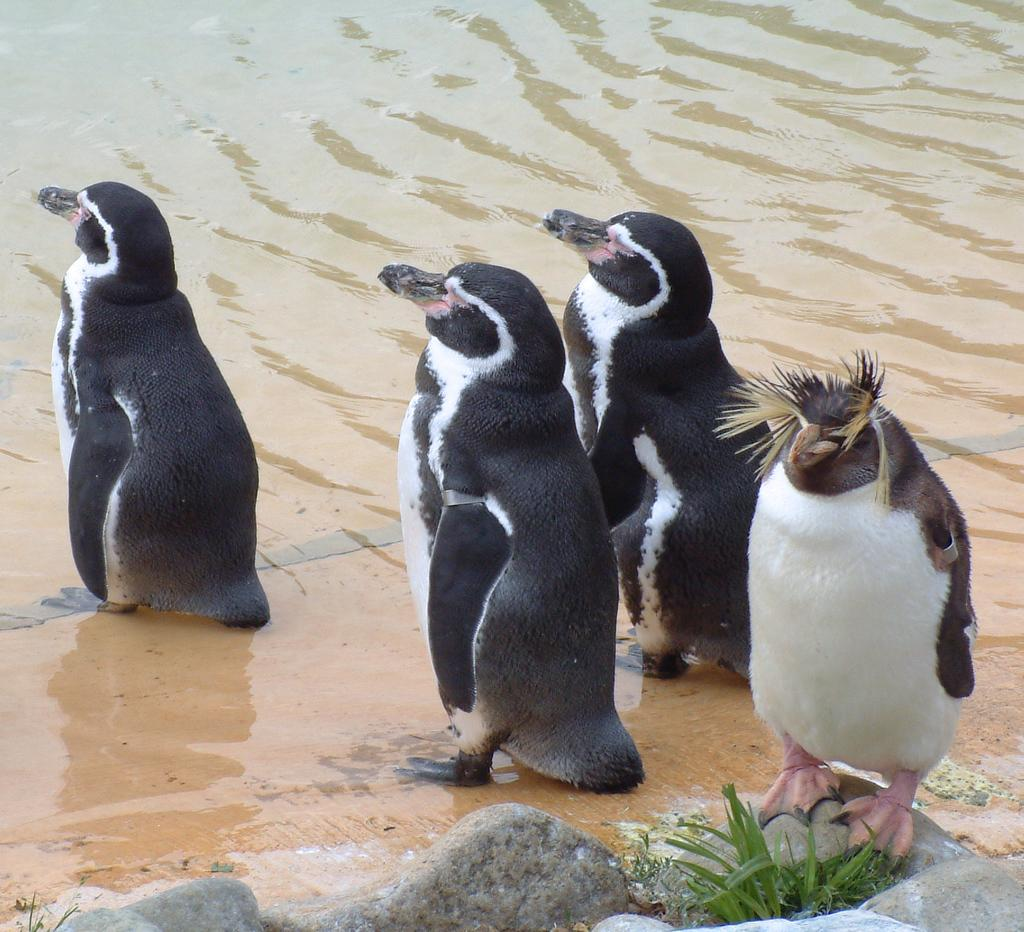What animals can be seen in the foreground of the image? There are four penguins in the foreground of the image. What type of environment is visible in the background of the image? There is a beach in the background of the image. What can be found at the bottom of the image? There are stones and grass at the bottom of the image. What type of straw is being used for distribution in the image? There is no straw or distribution process present in the image. 